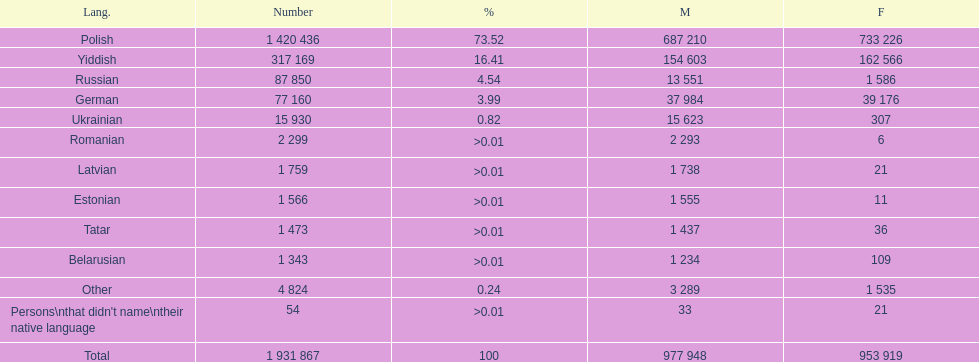Total of male speakers of russian 13 551. 